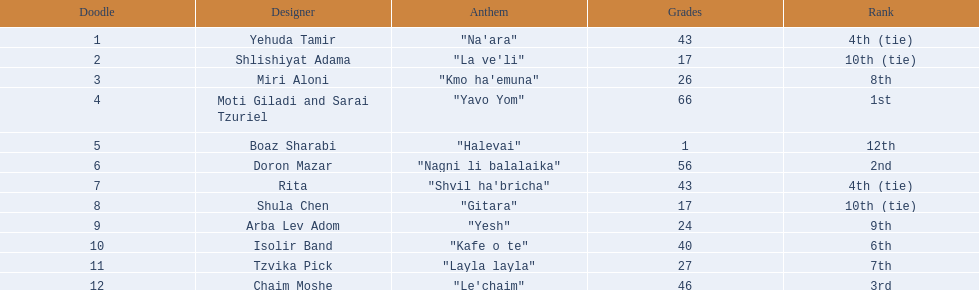What are the points? 43, 17, 26, 66, 1, 56, 43, 17, 24, 40, 27, 46. What is the least? 1. Which artist has that much Boaz Sharabi. 